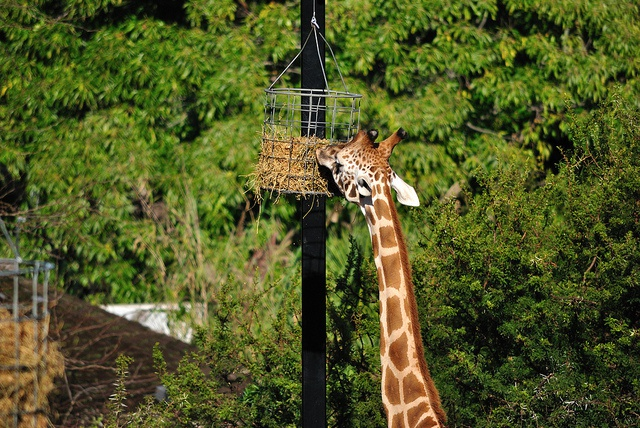Describe the objects in this image and their specific colors. I can see a giraffe in green, brown, tan, and ivory tones in this image. 